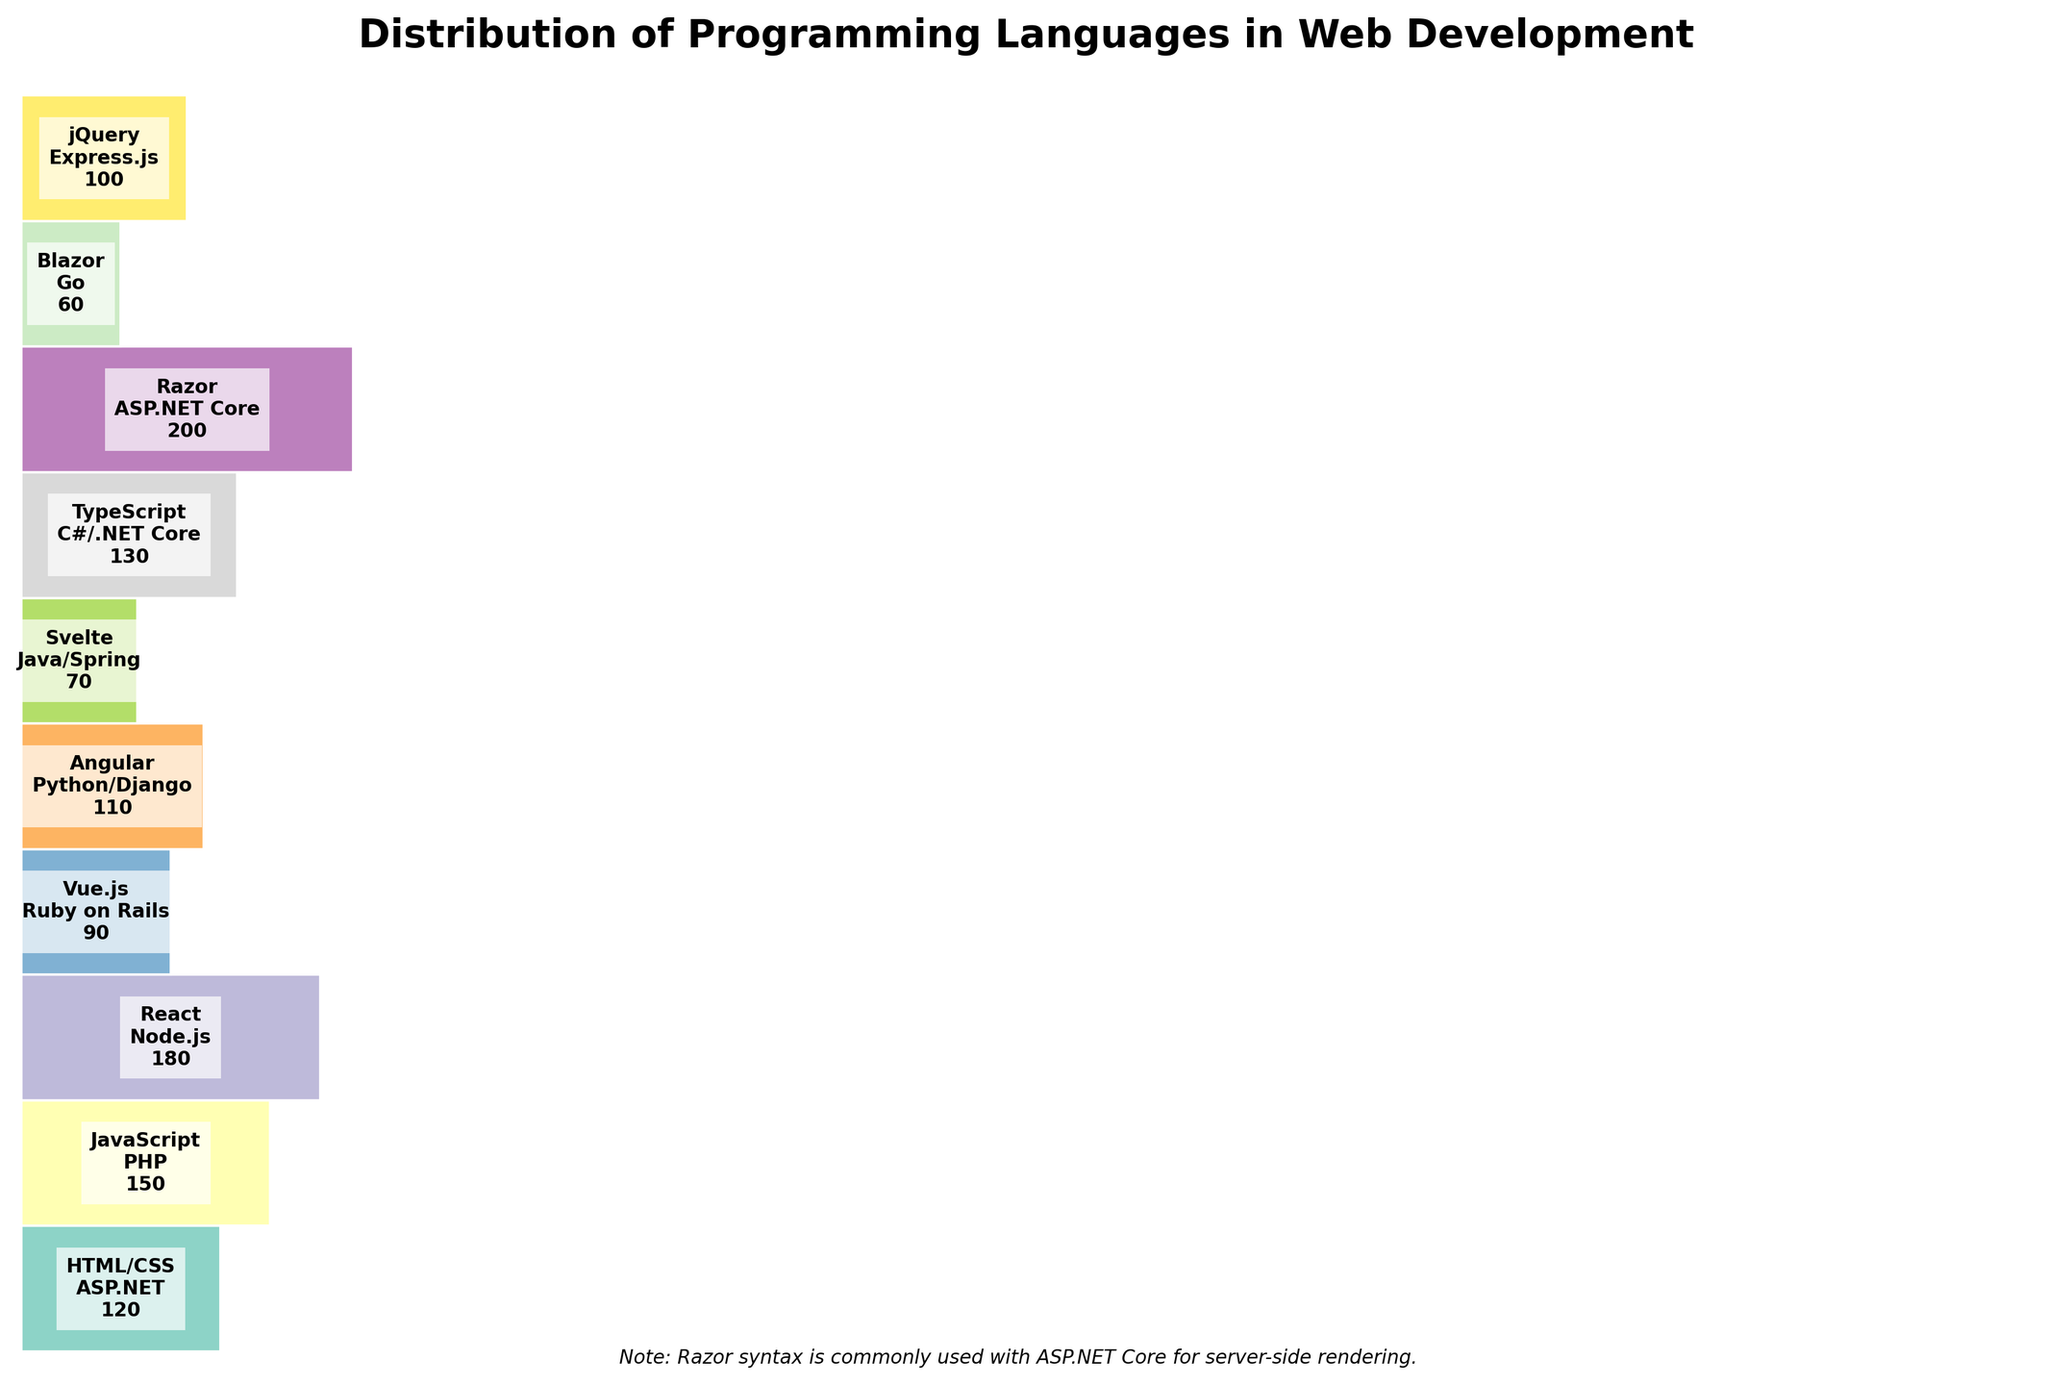What's the title of the mosaic plot? The title of the plot is located at the top, and it provides a brief description of what the plot is about. The title in this case is "Distribution of Programming Languages in Web Development".
Answer: Distribution of Programming Languages in Web Development Which frontend-backend combination has the highest count? By looking at the middle of each section in the mosaic plot, we can see the text labels. The combination of "Razor" (Frontend) and "ASP.NET Core" (Backend) has the highest count which is 200.
Answer: Razor - ASP.NET Core How many combinations have a count of 180 or above? By examining the text labels within the segments, only the combinations "Razor - ASP.NET Core" and "React - Node.js" have counts that meet or exceed 180.
Answer: 2 What is the color of the segment with the lowest count? The segment with the lowest count is "Blazor - Go" with 60. Its color can be identified by visual inspection of the plot. Since the colors are created using a color palette, it can be found towards the end of the color spectrum.
Answer: Towards the end of the color spectrum (e.g., often darker) Which frontend languages are paired with PHP and Go in the plot? The segment labels show the pairings. PHP is paired with "JavaScript" and Go is paired with "Blazor".
Answer: JavaScript and Blazor Who uses ASP.NET Core in their backend setup? We can identify the frontend language paired with ASP.NET Core by reading the labels. It is "Razor" that uses ASP.NET Core in their backend setup.
Answer: Razor If we add the counts of "React - Node.js" and "Angular - Python/Django", what is the total? By checking the counts in the middle of these segments, "React - Node.js" has 180 and "Angular - Python/Django" has 110. Adding these gives 180 + 110 = 290.
Answer: 290 Which combination is more frequent, "JavaScript - PHP" or "Vue.js - Ruby on Rails"? By comparing the counts in the segments, "JavaScript - PHP" has 150 and "Vue.js - Ruby on Rails" has 90. So, "JavaScript - PHP" is more frequent.
Answer: JavaScript - PHP What note is included at the bottom of the plot? The footnote at the bottom provides additional information, and it reads: "Note: Razor syntax is commonly used with ASP.NET Core for server-side rendering."
Answer: Note: Razor syntax is commonly used with ASP.NET Core for server-side rendering How many unique frontend languages are used in the projects shown in the plot? We can count the distinct frontend languages from the list of segments in the mosaic plot. The frontend languages listed are: HTML/CSS, JavaScript, React, Vue.js, Angular, Svelte, TypeScript, Razor, Blazor, jQuery, totaling 10 unique frontend languages.
Answer: 10 